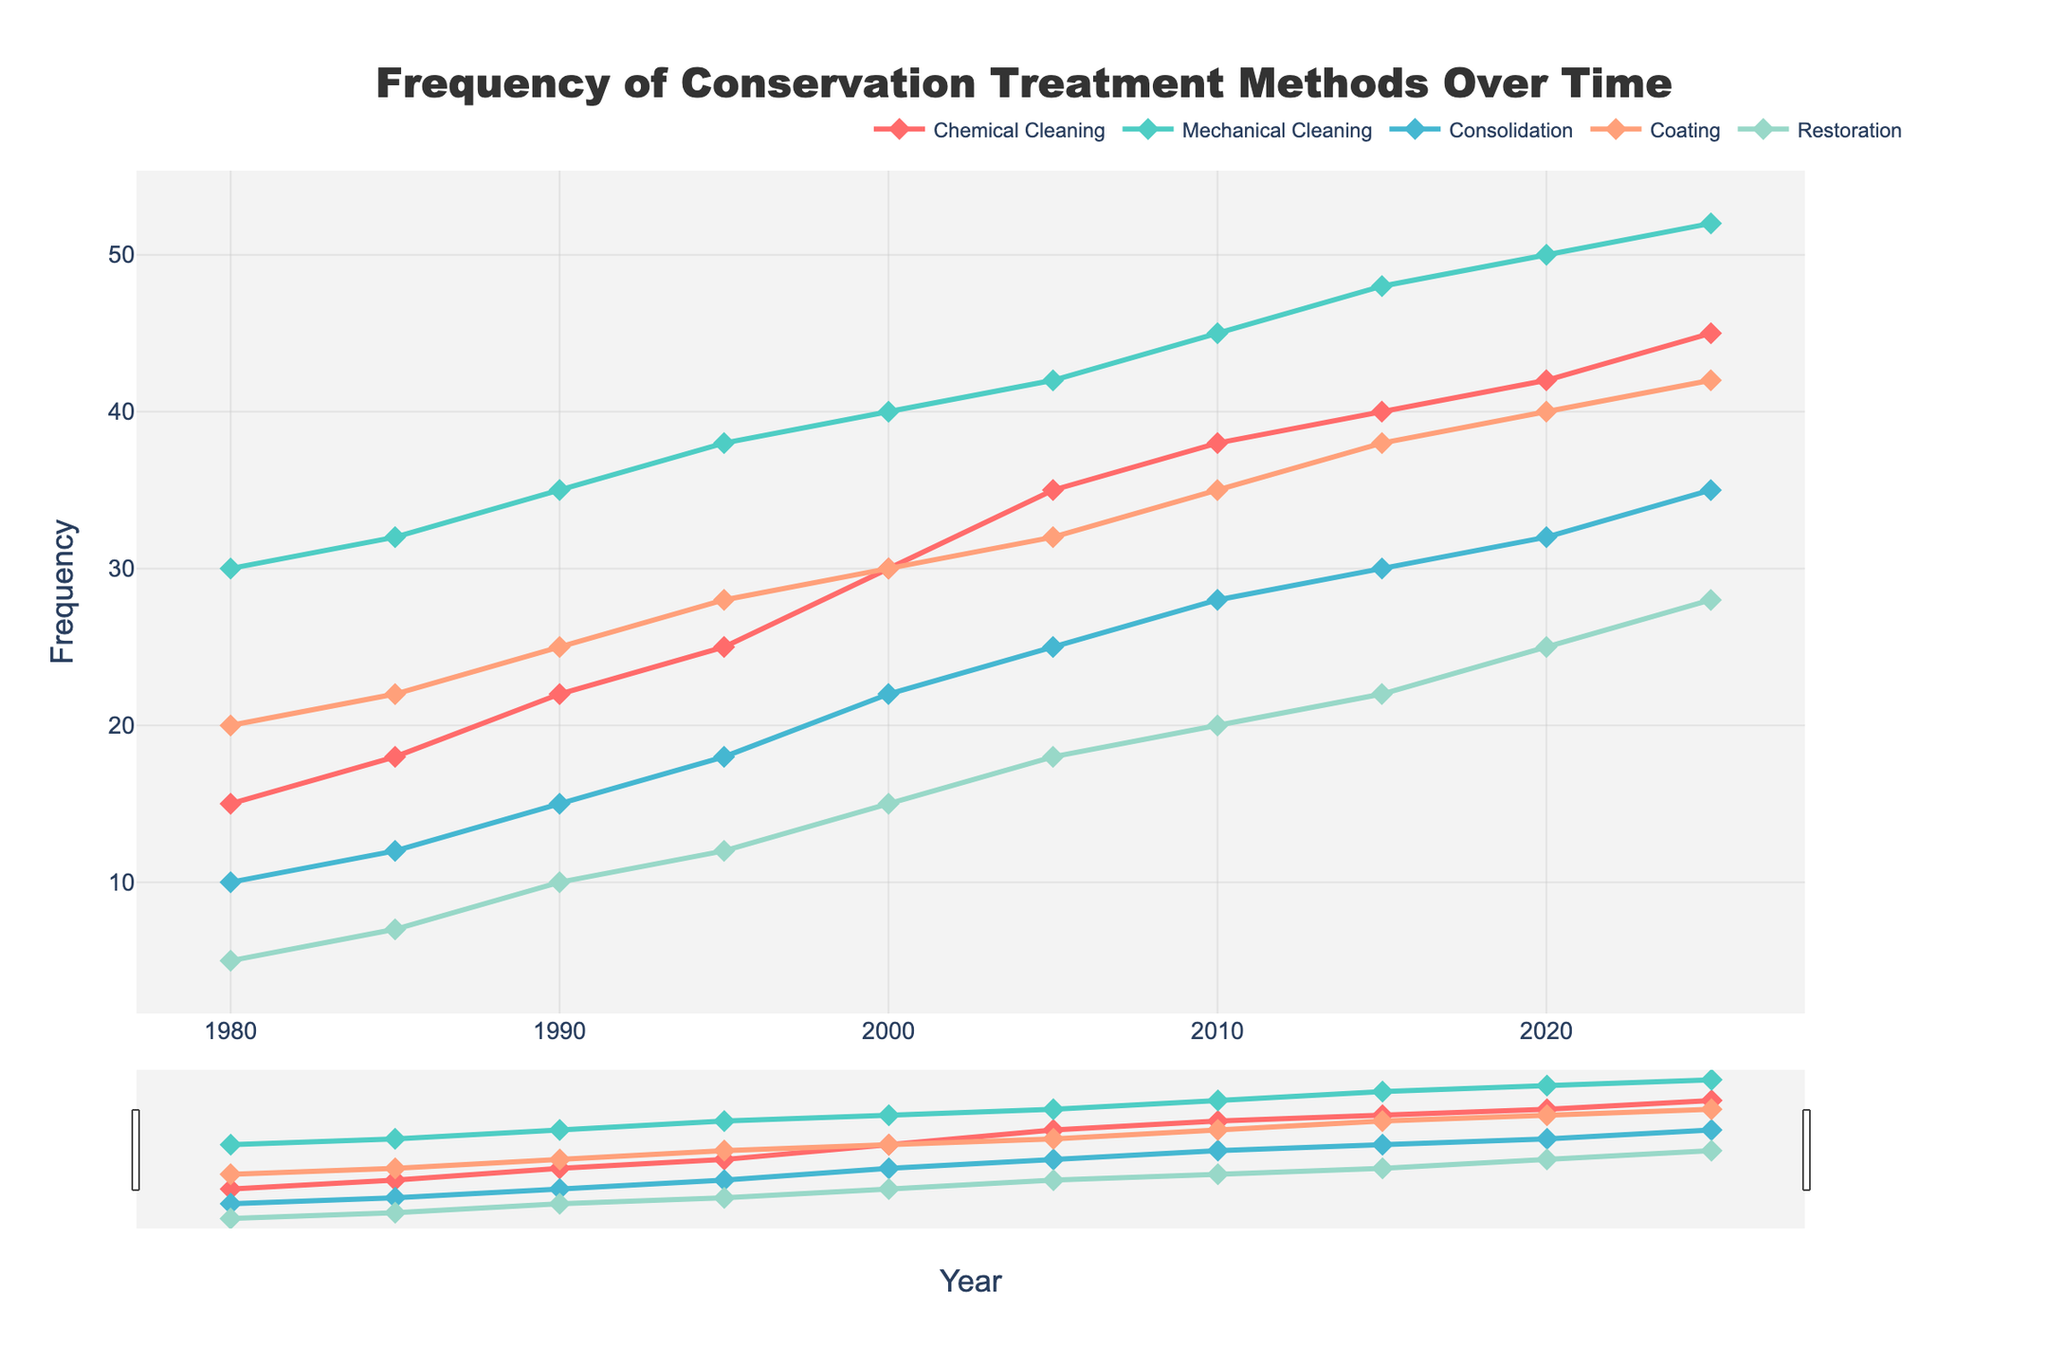What is the frequency of Mechanical Cleaning in the year 2020? Look at the line corresponding to Mechanical Cleaning and identify the marker for the year 2020. Read the value labeled next to the marker.
Answer: 50 How many more times was Consolidation applied than Restoration in the year 2025? Identify the values for Consolidation and Restoration in 2025. Calculate the difference: Consolidation (35) - Restoration (28) = 7
Answer: 7 Which treatment method has shown the greatest increase in frequency from 1980 to 2025? Compare the initial and final values for each treatment method. Calculate the increase for each: 
- Chemical Cleaning: 45 - 15 = 30,
- Mechanical Cleaning: 52 - 30 = 22,
- Consolidation: 35 - 10 = 25,
- Coating: 42 - 20 = 22,
- Restoration: 28 - 5 = 23.
The greatest increase is for Chemical Cleaning.
Answer: Chemical Cleaning In which year did Chemical Cleaning frequency surpass 30? Observe the line for Chemical Cleaning and identify where it crosses the frequency value of 30. This occurs between the years 1995 and 2000.
Answer: 2000 What is the combined frequency of all treatment methods in the year 1995? Sum the frequencies of all methods for the year 1995: Mechanical Cleaning (38) + Chemical Cleaning (25) + Consolidation (18) + Coating (28) + Restoration (12) = 121
Answer: 121 Which treatment method had the least frequency in the year 2015? Compare the frequencies in 2015: Chemical Cleaning (40), Mechanical Cleaning (48), Consolidation (30), Coating (38), and Restoration (22). The lowest value is for Restoration.
Answer: Restoration Between which two years did Mechanical Cleaning show the highest increment in frequency? Calculate the increments for each time period:
- 1980-1985: 32 - 30 = 2,
- 1985-1990: 35 - 32 = 3,
- 1990-1995: 38 - 35 = 3,
- 1995-2000: 40 - 38 = 2,
- 2000-2005: 42 - 40 = 2,
- 2005-2010: 45 - 42 = 3,
- 2010-2015: 48 - 45 = 3,
- 2015-2020: 50 - 48 = 2,
- 2020-2025: 52 - 50 = 2.
The highest increments are from 1985-1990, 1990-1995, 2005-2010, and 2010-2015, which are all equal and highest.
Answer: 1985-1990, 1990-1995, 2005-2010, 2010-2015 What is the average frequency of Coating between 1980 and 2025? Sum the Coating frequencies over all years and divide by the number of years (10): 
(20 + 22 + 25 + 28 + 30 + 32 + 35 + 38 + 40 + 42)/10 = 312/10 = 31.2
Answer: 31.2 